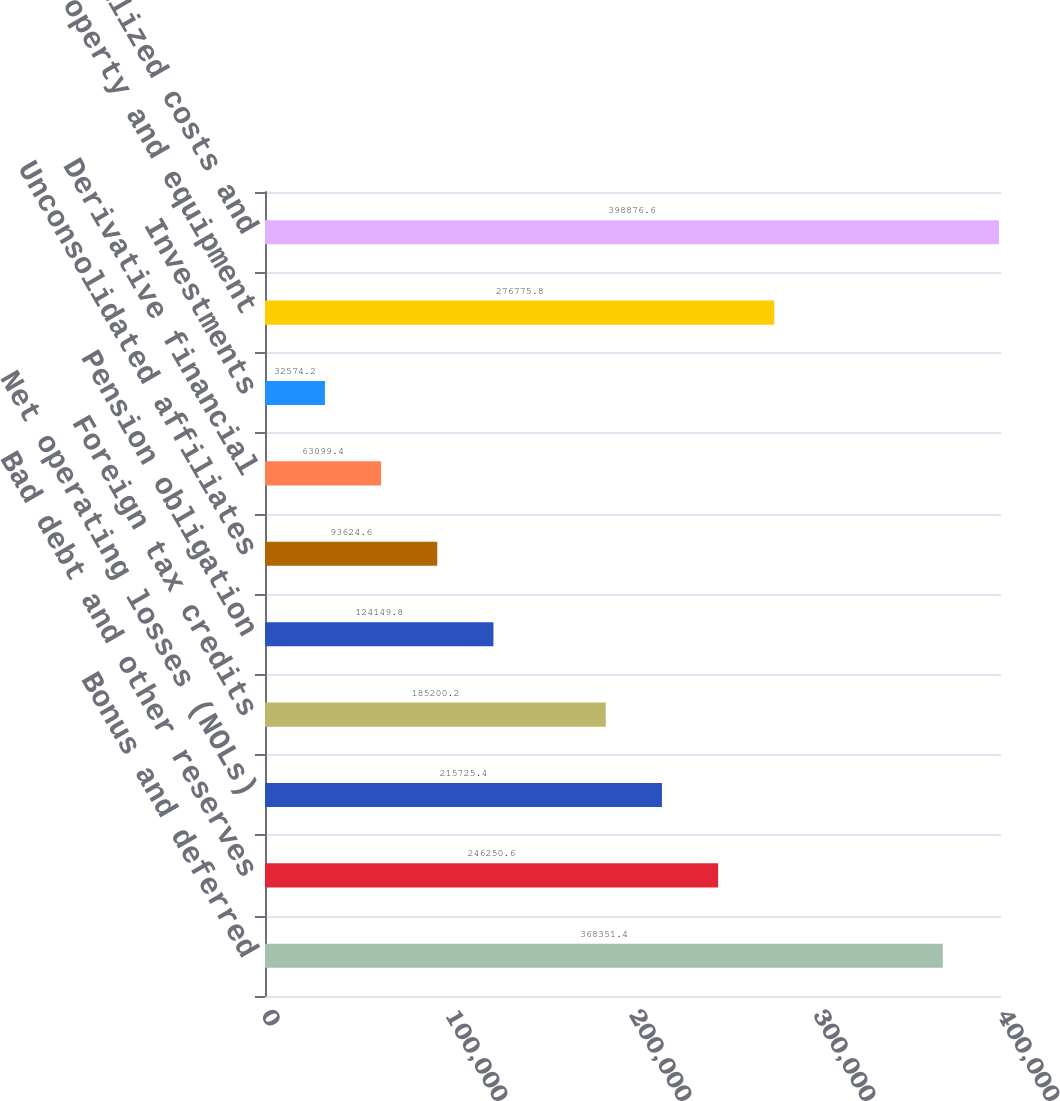Convert chart to OTSL. <chart><loc_0><loc_0><loc_500><loc_500><bar_chart><fcel>Bonus and deferred<fcel>Bad debt and other reserves<fcel>Net operating losses (NOLs)<fcel>Foreign tax credits<fcel>Pension obligation<fcel>Unconsolidated affiliates<fcel>Derivative financial<fcel>Investments<fcel>Property and equipment<fcel>Capitalized costs and<nl><fcel>368351<fcel>246251<fcel>215725<fcel>185200<fcel>124150<fcel>93624.6<fcel>63099.4<fcel>32574.2<fcel>276776<fcel>398877<nl></chart> 